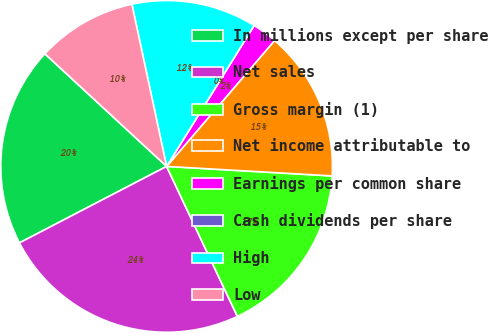<chart> <loc_0><loc_0><loc_500><loc_500><pie_chart><fcel>In millions except per share<fcel>Net sales<fcel>Gross margin (1)<fcel>Net income attributable to<fcel>Earnings per common share<fcel>Cash dividends per share<fcel>High<fcel>Low<nl><fcel>19.51%<fcel>24.39%<fcel>17.07%<fcel>14.63%<fcel>2.44%<fcel>0.0%<fcel>12.2%<fcel>9.76%<nl></chart> 